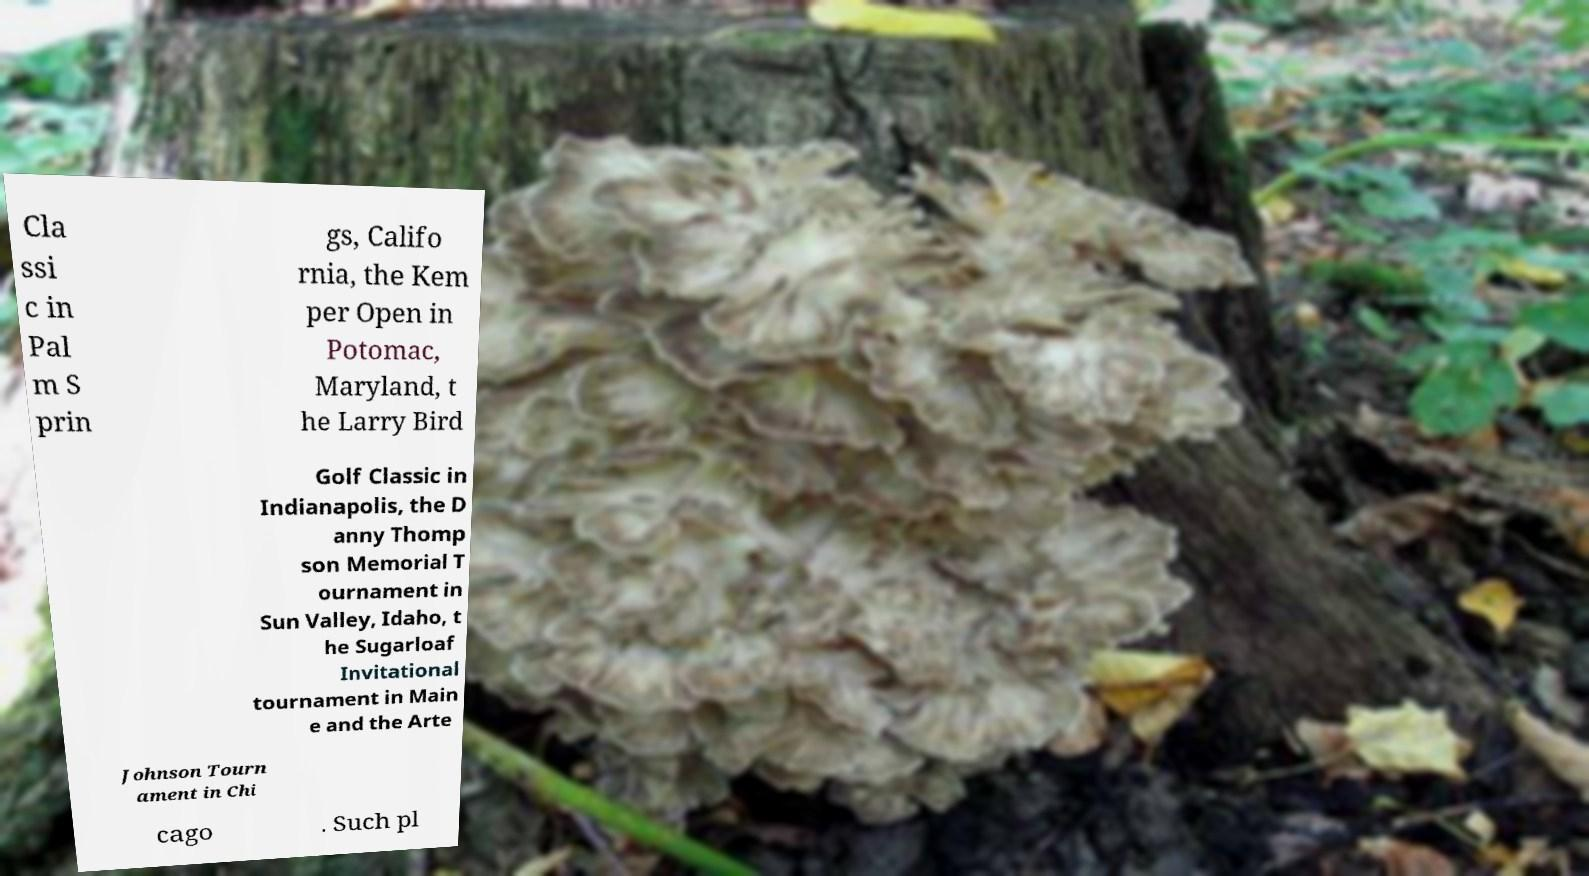Could you extract and type out the text from this image? Cla ssi c in Pal m S prin gs, Califo rnia, the Kem per Open in Potomac, Maryland, t he Larry Bird Golf Classic in Indianapolis, the D anny Thomp son Memorial T ournament in Sun Valley, Idaho, t he Sugarloaf Invitational tournament in Main e and the Arte Johnson Tourn ament in Chi cago . Such pl 